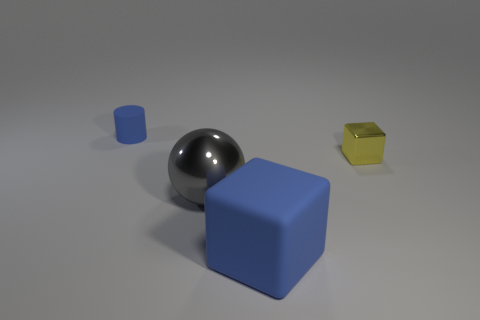Add 4 tiny shiny cylinders. How many objects exist? 8 Subtract all spheres. How many objects are left? 3 Add 3 big balls. How many big balls are left? 4 Add 2 large brown shiny spheres. How many large brown shiny spheres exist? 2 Subtract 0 gray cylinders. How many objects are left? 4 Subtract all large blocks. Subtract all metal cubes. How many objects are left? 2 